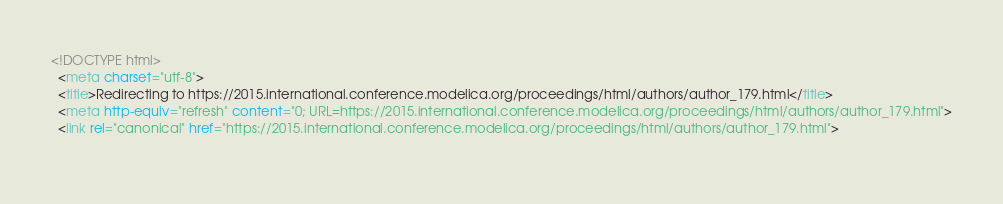Convert code to text. <code><loc_0><loc_0><loc_500><loc_500><_HTML_><!DOCTYPE html>
  <meta charset="utf-8">
  <title>Redirecting to https://2015.international.conference.modelica.org/proceedings/html/authors/author_179.html</title>
  <meta http-equiv="refresh" content="0; URL=https://2015.international.conference.modelica.org/proceedings/html/authors/author_179.html">
  <link rel="canonical" href="https://2015.international.conference.modelica.org/proceedings/html/authors/author_179.html">
  </code> 